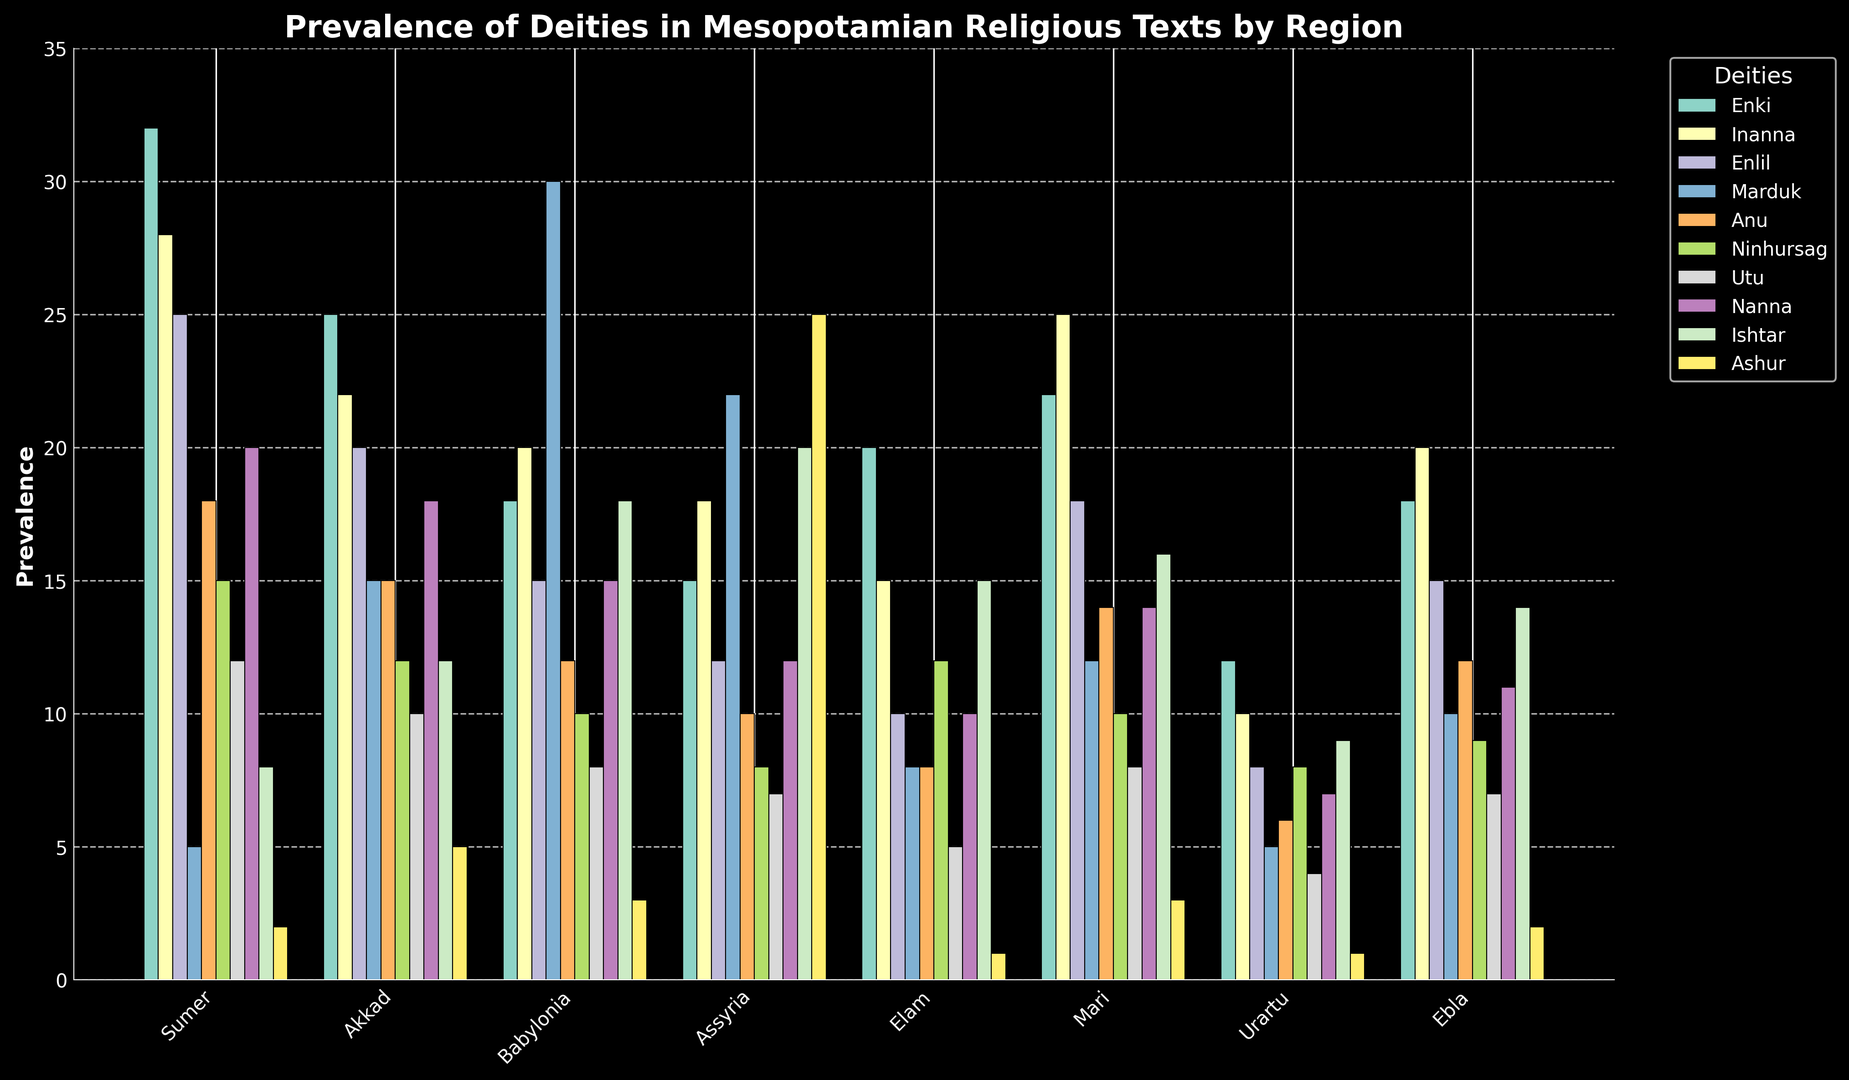Which region shows the highest prevalence of Marduk? The bar for Marduk is highest in Babylonian region compared to the other regions
Answer: Babylonia Among the deities, which one is the least prevalent in the Sumer region? In the Sumer region, the bar for Ashur is the lowest among all deities
Answer: Ashur Compare the prevalence of Enki across Sumer and Akkad. Which region has a higher prevalence? The bar for Enki is higher in Sumer (32) compared to Akkad (25)
Answer: Sumer What's the sum of the prevalence counts of Enlil and Inanna in the Assyria region? Enlil in Assyria is 12 and Inanna is 18, so adding them together we get 12 + 18 = 30
Answer: 30 Which deity has a higher prevalence in Mari, Ninhursag or Anu? Comparing the bars for Ninhursag and Anu in Mari, Ninhursag has a count of 10 and Anu has 14, so Anu is higher
Answer: Anu In which region is Ishtar more prevalent, Babylonia or Mari? Comparing the bars for Ishtar in Babylonia (18) and Mari (16), Ishtar is more prevalent in Babylonia
Answer: Babylonia Which deity has the highest cumulative prevalence across all regions? Adding the counts for all the regions, Enki has the highest cumulative prevalence of 162
Answer: Enki What is the average prevalence of the deity Utu in all regions? Summing up the counts of Utu (12+10+8+7+5+8+4+7 = 61) and dividing by 8 regions, the average is 61 / 8 = 7.625
Answer: 7.625 By how much does the prevalence of Ashur in Assyria exceed its prevalence in Sumer? The prevalence of Ashur in Assyria is 25 and in Sumer is 2, so the difference is 25 - 2 = 23
Answer: 23 